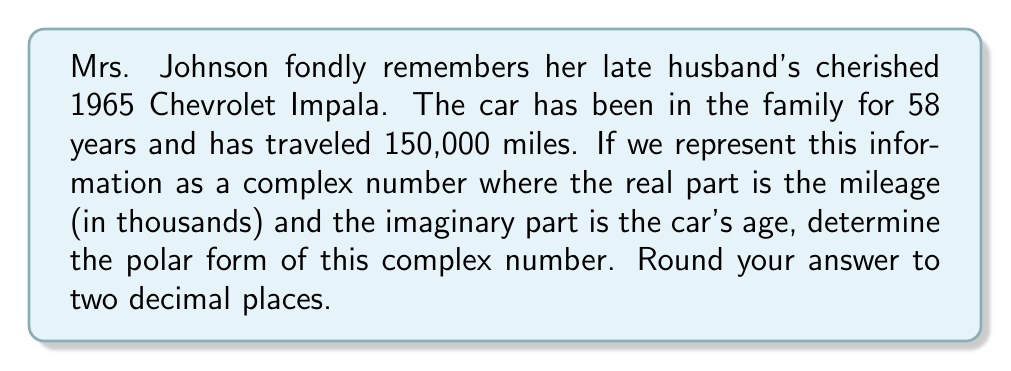Solve this math problem. Let's approach this step-by-step:

1) First, we need to form our complex number. 
   $z = 150 + 58i$

2) To convert this to polar form, we need to find the modulus $r$ and the argument $\theta$.

3) The modulus $r$ is given by:
   $$r = \sqrt{a^2 + b^2} = \sqrt{150^2 + 58^2} = \sqrt{22500 + 3364} = \sqrt{25864} \approx 160.82$$

4) The argument $\theta$ is given by:
   $$\theta = \tan^{-1}\left(\frac{b}{a}\right) = \tan^{-1}\left(\frac{58}{150}\right) \approx 0.3684 \text{ radians}$$

5) We need to convert this to degrees:
   $$0.3684 \text{ radians} \times \frac{180^\circ}{\pi} \approx 21.11^\circ$$

6) Therefore, the polar form is:
   $$z = r(\cos\theta + i\sin\theta) \approx 160.82(\cos 21.11^\circ + i\sin 21.11^\circ)$$

   Or in the more compact form:
   $$z \approx 160.82 \angle 21.11^\circ$$
Answer: $z \approx 160.82 \angle 21.11^\circ$ 